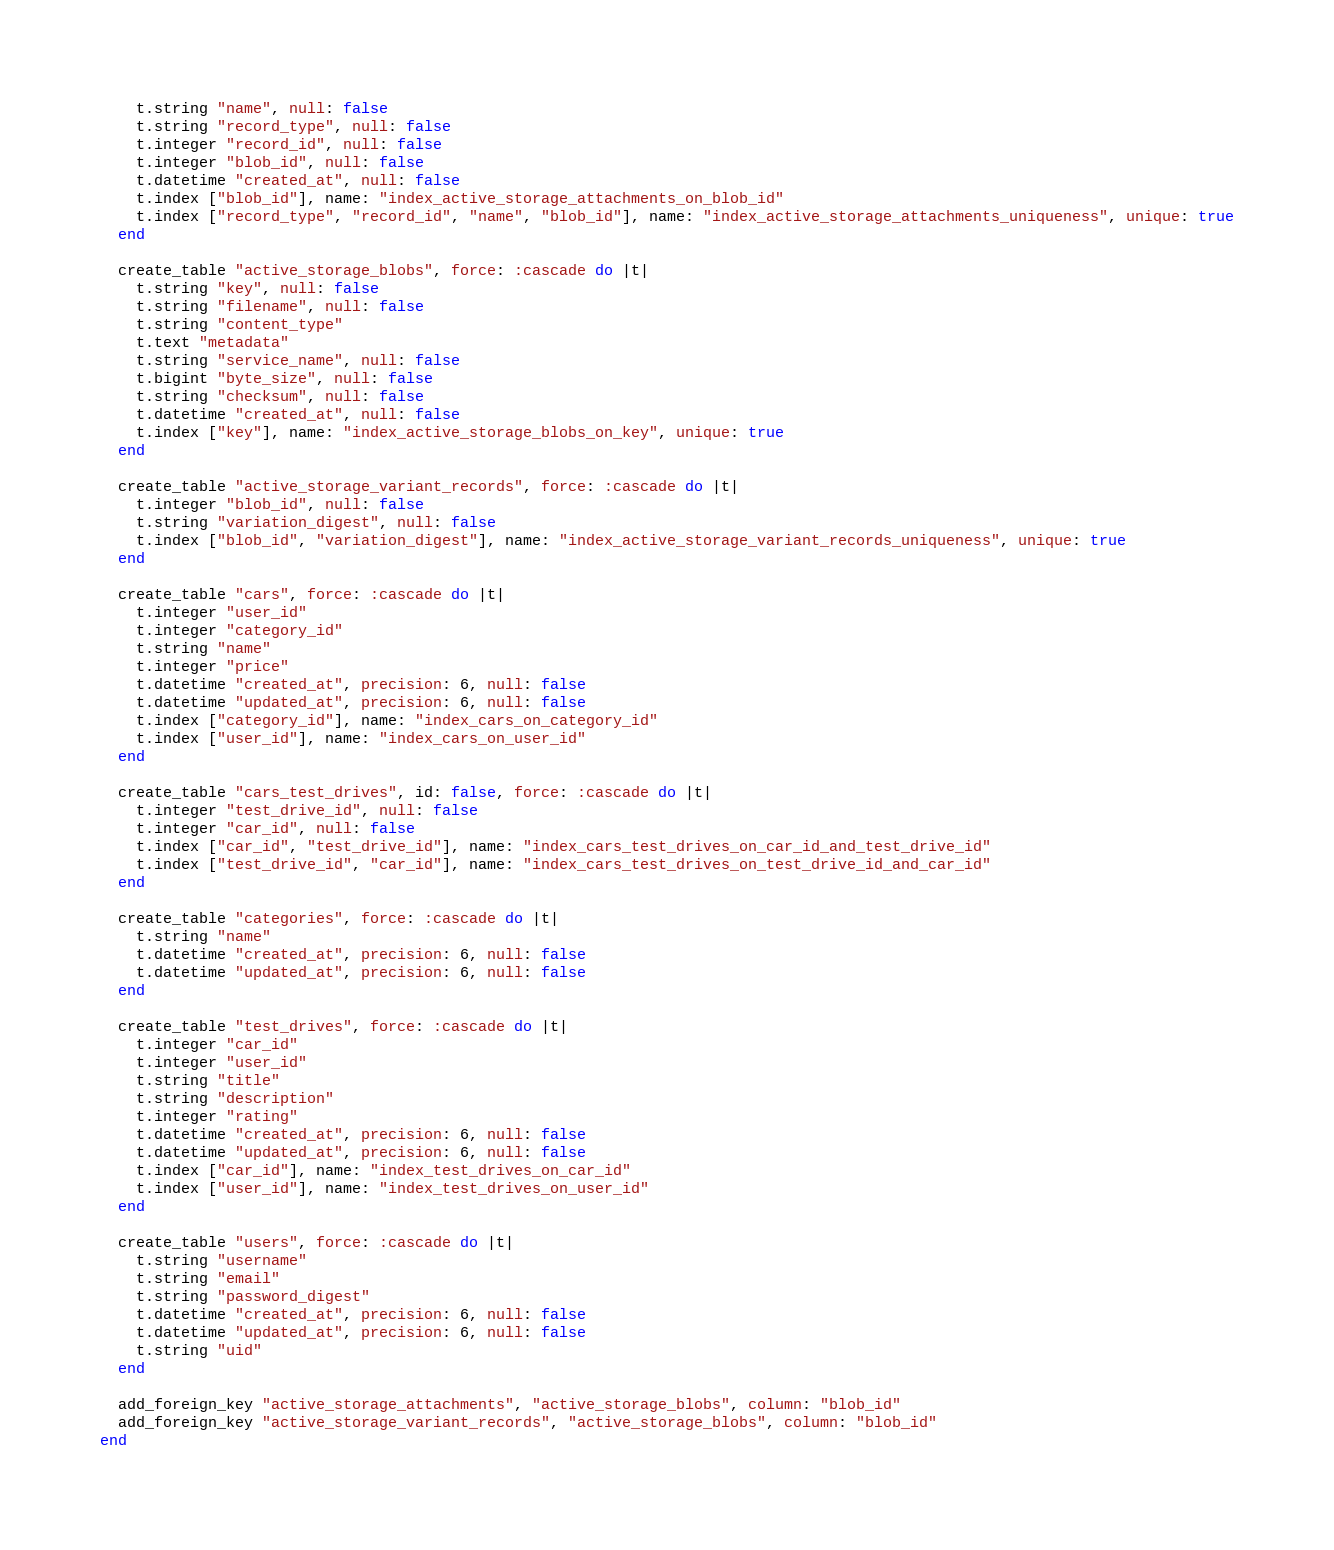<code> <loc_0><loc_0><loc_500><loc_500><_Ruby_>    t.string "name", null: false
    t.string "record_type", null: false
    t.integer "record_id", null: false
    t.integer "blob_id", null: false
    t.datetime "created_at", null: false
    t.index ["blob_id"], name: "index_active_storage_attachments_on_blob_id"
    t.index ["record_type", "record_id", "name", "blob_id"], name: "index_active_storage_attachments_uniqueness", unique: true
  end

  create_table "active_storage_blobs", force: :cascade do |t|
    t.string "key", null: false
    t.string "filename", null: false
    t.string "content_type"
    t.text "metadata"
    t.string "service_name", null: false
    t.bigint "byte_size", null: false
    t.string "checksum", null: false
    t.datetime "created_at", null: false
    t.index ["key"], name: "index_active_storage_blobs_on_key", unique: true
  end

  create_table "active_storage_variant_records", force: :cascade do |t|
    t.integer "blob_id", null: false
    t.string "variation_digest", null: false
    t.index ["blob_id", "variation_digest"], name: "index_active_storage_variant_records_uniqueness", unique: true
  end

  create_table "cars", force: :cascade do |t|
    t.integer "user_id"
    t.integer "category_id"
    t.string "name"
    t.integer "price"
    t.datetime "created_at", precision: 6, null: false
    t.datetime "updated_at", precision: 6, null: false
    t.index ["category_id"], name: "index_cars_on_category_id"
    t.index ["user_id"], name: "index_cars_on_user_id"
  end

  create_table "cars_test_drives", id: false, force: :cascade do |t|
    t.integer "test_drive_id", null: false
    t.integer "car_id", null: false
    t.index ["car_id", "test_drive_id"], name: "index_cars_test_drives_on_car_id_and_test_drive_id"
    t.index ["test_drive_id", "car_id"], name: "index_cars_test_drives_on_test_drive_id_and_car_id"
  end

  create_table "categories", force: :cascade do |t|
    t.string "name"
    t.datetime "created_at", precision: 6, null: false
    t.datetime "updated_at", precision: 6, null: false
  end

  create_table "test_drives", force: :cascade do |t|
    t.integer "car_id"
    t.integer "user_id"
    t.string "title"
    t.string "description"
    t.integer "rating"
    t.datetime "created_at", precision: 6, null: false
    t.datetime "updated_at", precision: 6, null: false
    t.index ["car_id"], name: "index_test_drives_on_car_id"
    t.index ["user_id"], name: "index_test_drives_on_user_id"
  end

  create_table "users", force: :cascade do |t|
    t.string "username"
    t.string "email"
    t.string "password_digest"
    t.datetime "created_at", precision: 6, null: false
    t.datetime "updated_at", precision: 6, null: false
    t.string "uid"
  end

  add_foreign_key "active_storage_attachments", "active_storage_blobs", column: "blob_id"
  add_foreign_key "active_storage_variant_records", "active_storage_blobs", column: "blob_id"
end
</code> 